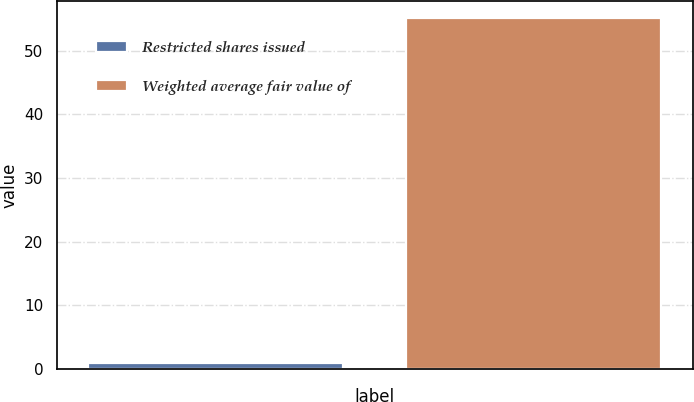<chart> <loc_0><loc_0><loc_500><loc_500><bar_chart><fcel>Restricted shares issued<fcel>Weighted average fair value of<nl><fcel>0.9<fcel>55.09<nl></chart> 